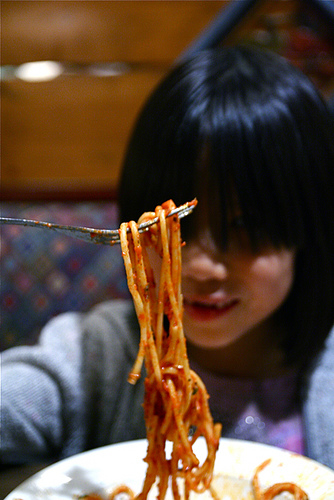<image>
Is there a noodles behind the girl? No. The noodles is not behind the girl. From this viewpoint, the noodles appears to be positioned elsewhere in the scene. Is the spaghetti in the girl? No. The spaghetti is not contained within the girl. These objects have a different spatial relationship. Where is the pasta in relation to the cheek? Is it in front of the cheek? Yes. The pasta is positioned in front of the cheek, appearing closer to the camera viewpoint. 